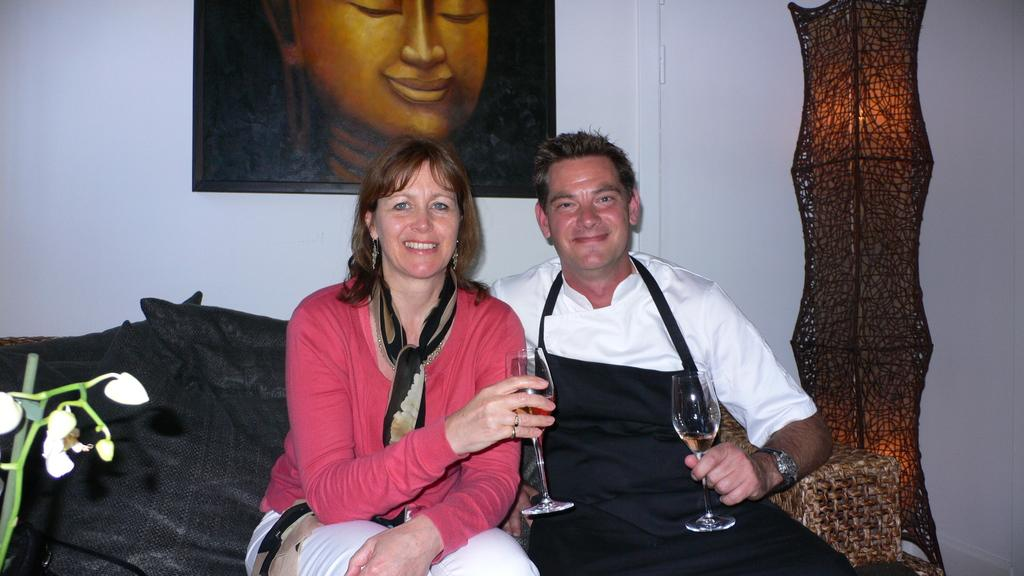How many people are sitting on the couch in the image? There are two persons sitting on the couch in the image. What are the persons doing on the couch? The persons are sitting and smiling. What are the persons holding in their hands? The persons are holding wine glasses. What can be seen in the background of the image? There is a wall in the background, and a photo frame is on the wall. What is the rate of the cable in the image? There is no cable present in the image, so it is not possible to determine the rate. 